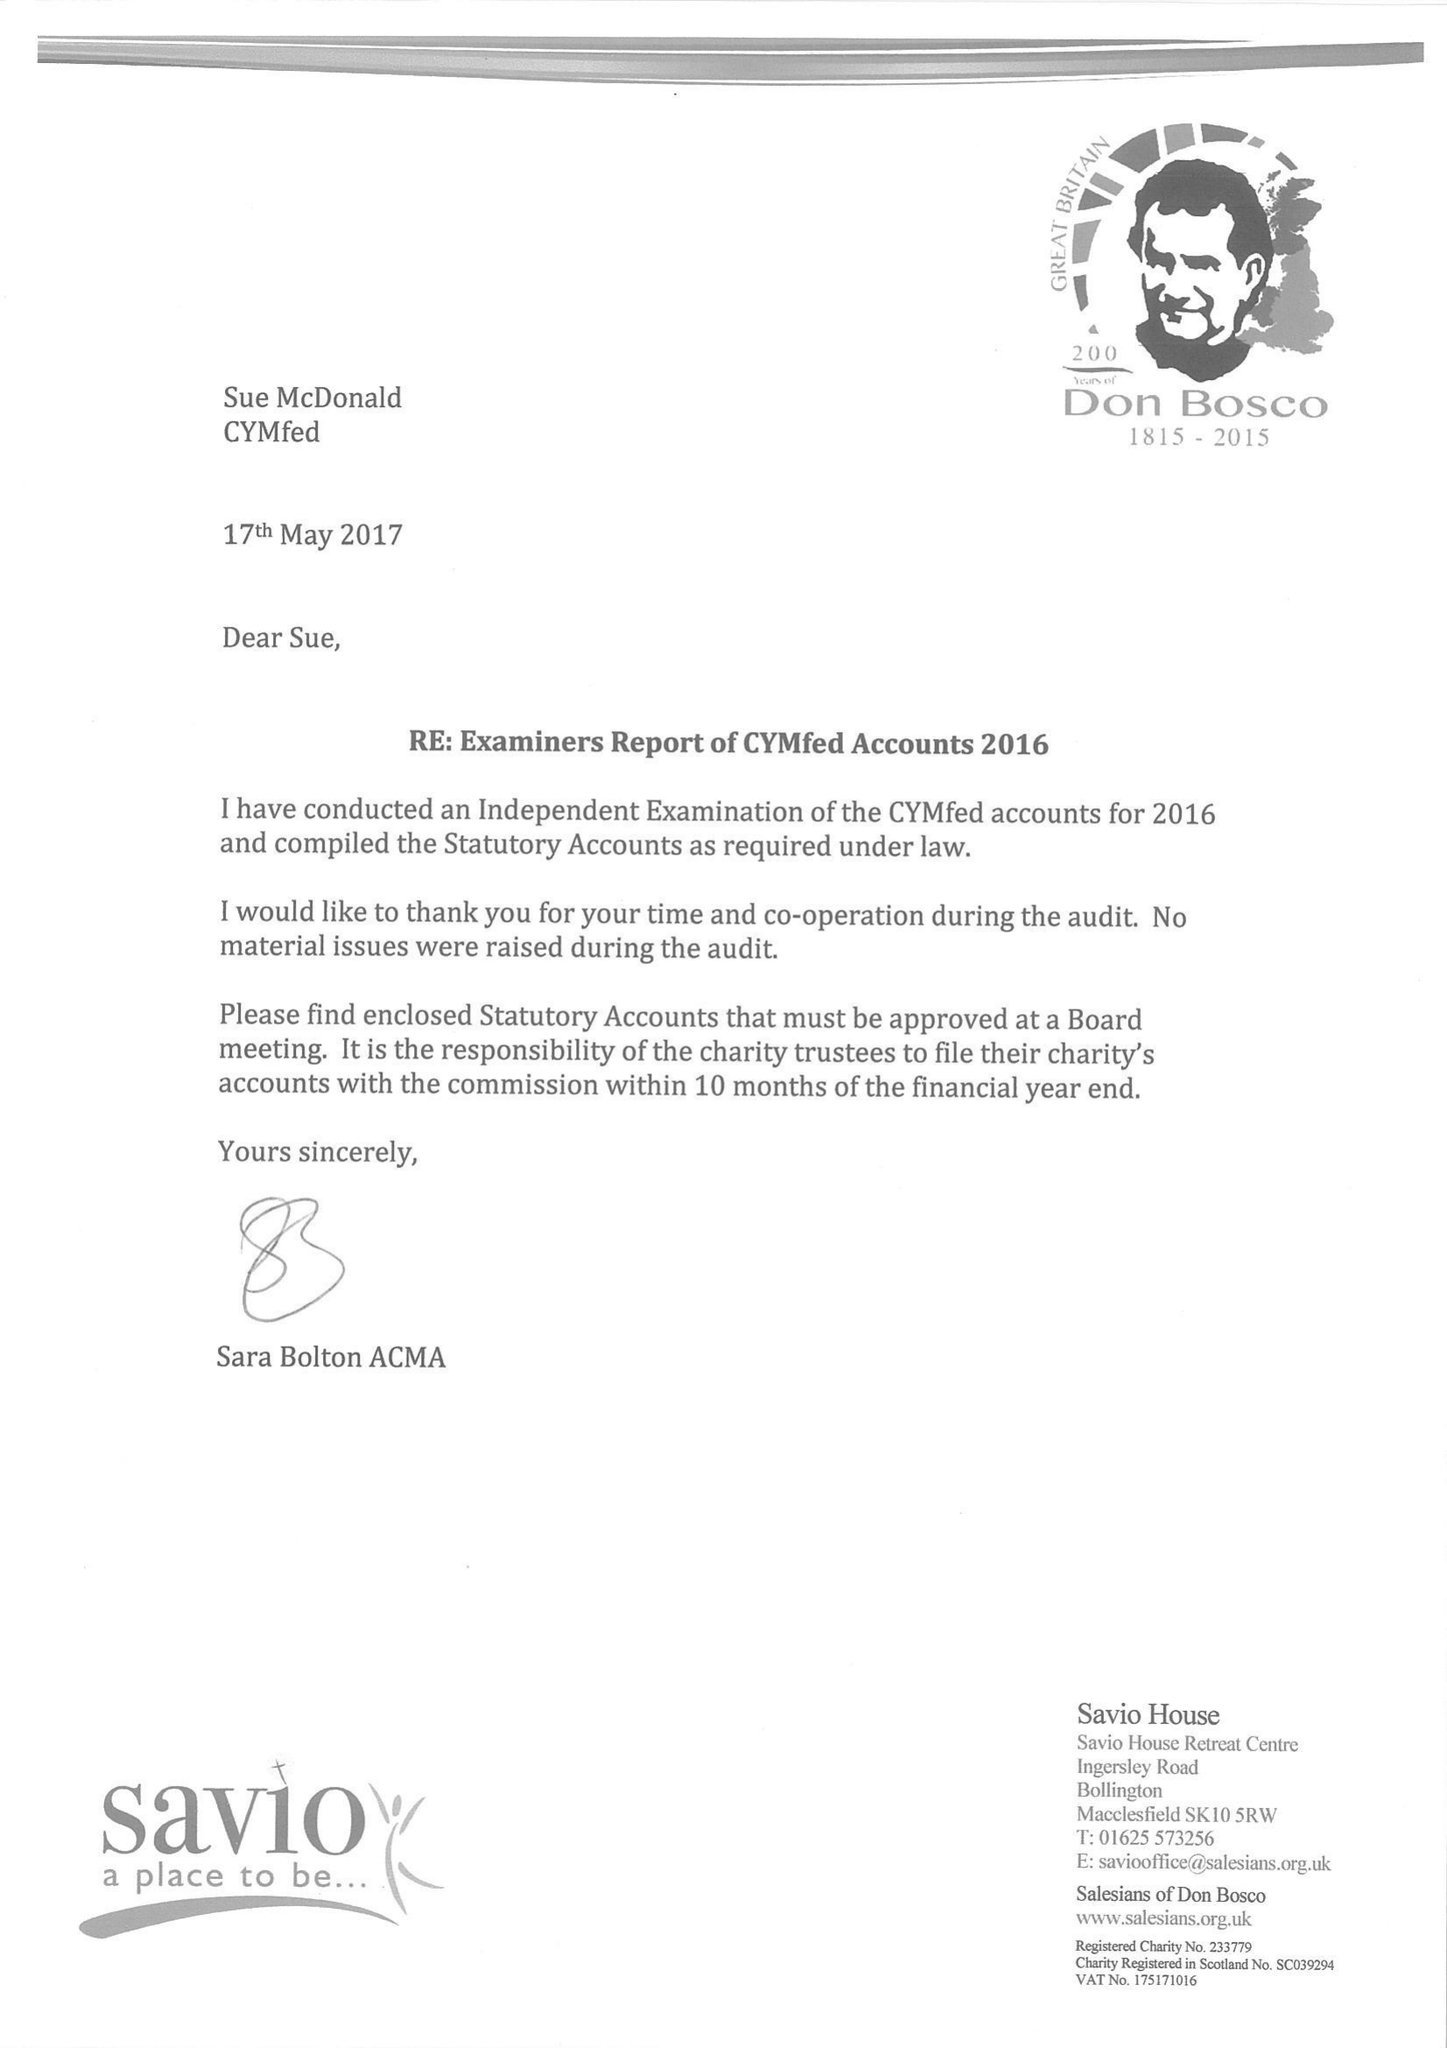What is the value for the charity_number?
Answer the question using a single word or phrase. None 